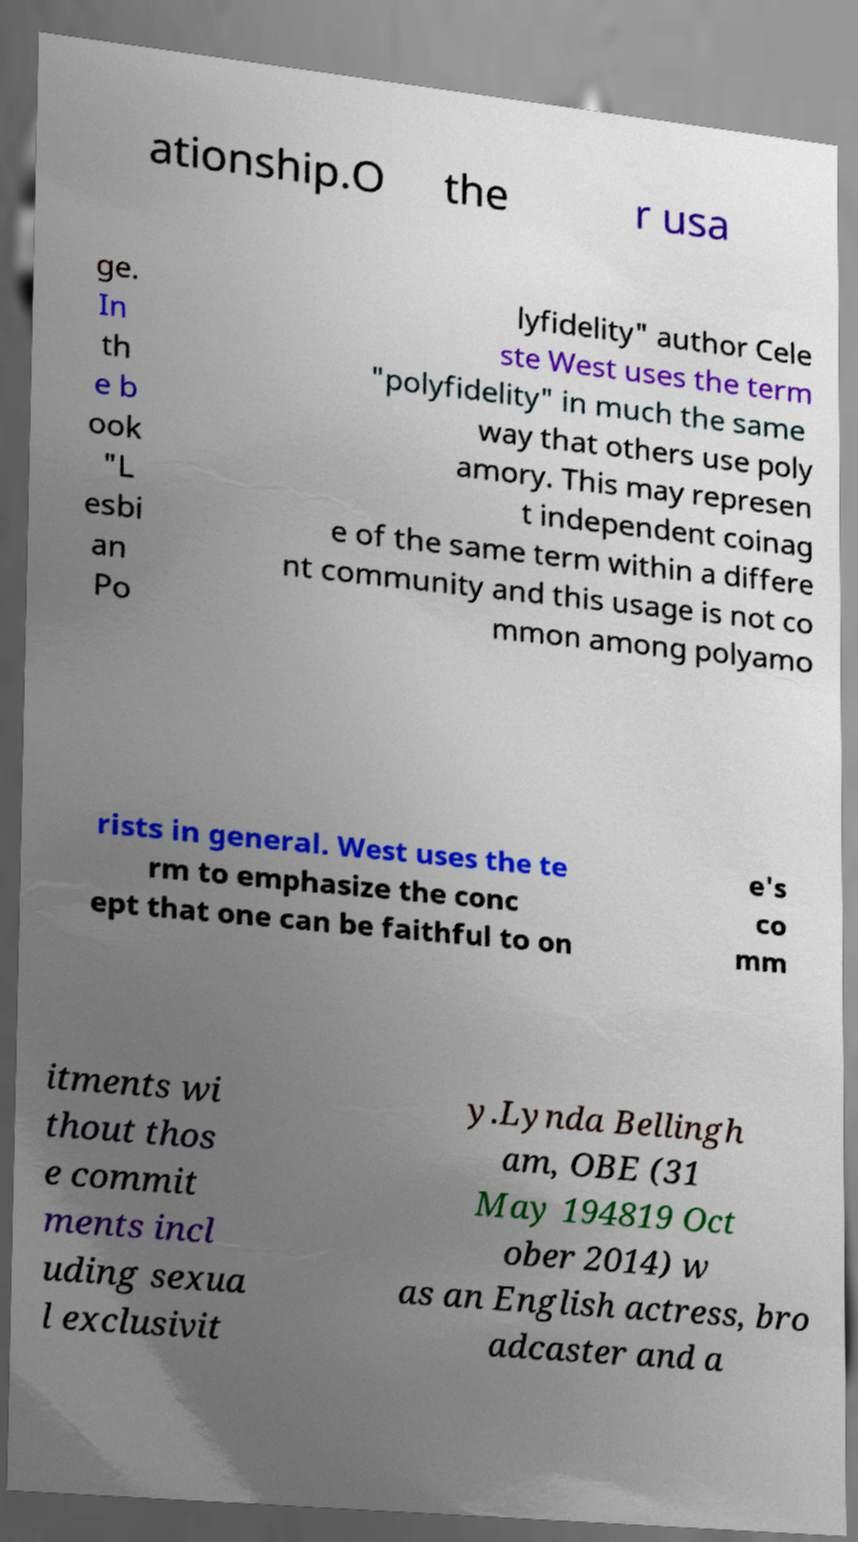What messages or text are displayed in this image? I need them in a readable, typed format. ationship.O the r usa ge. In th e b ook "L esbi an Po lyfidelity" author Cele ste West uses the term "polyfidelity" in much the same way that others use poly amory. This may represen t independent coinag e of the same term within a differe nt community and this usage is not co mmon among polyamo rists in general. West uses the te rm to emphasize the conc ept that one can be faithful to on e's co mm itments wi thout thos e commit ments incl uding sexua l exclusivit y.Lynda Bellingh am, OBE (31 May 194819 Oct ober 2014) w as an English actress, bro adcaster and a 